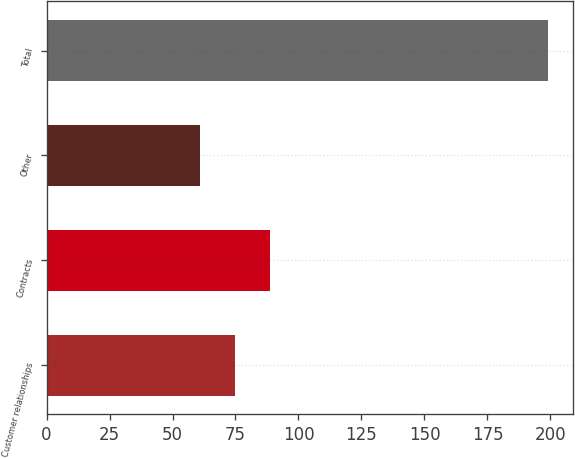Convert chart to OTSL. <chart><loc_0><loc_0><loc_500><loc_500><bar_chart><fcel>Customer relationships<fcel>Contracts<fcel>Other<fcel>Total<nl><fcel>74.8<fcel>88.6<fcel>61<fcel>199<nl></chart> 